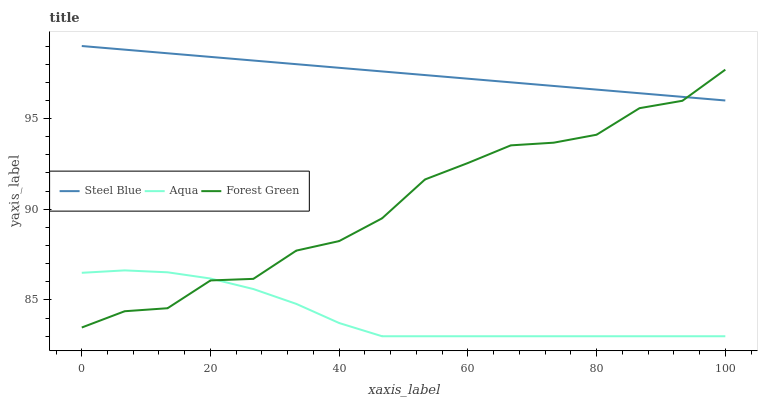Does Steel Blue have the minimum area under the curve?
Answer yes or no. No. Does Aqua have the maximum area under the curve?
Answer yes or no. No. Is Aqua the smoothest?
Answer yes or no. No. Is Aqua the roughest?
Answer yes or no. No. Does Steel Blue have the lowest value?
Answer yes or no. No. Does Aqua have the highest value?
Answer yes or no. No. Is Aqua less than Steel Blue?
Answer yes or no. Yes. Is Steel Blue greater than Aqua?
Answer yes or no. Yes. Does Aqua intersect Steel Blue?
Answer yes or no. No. 